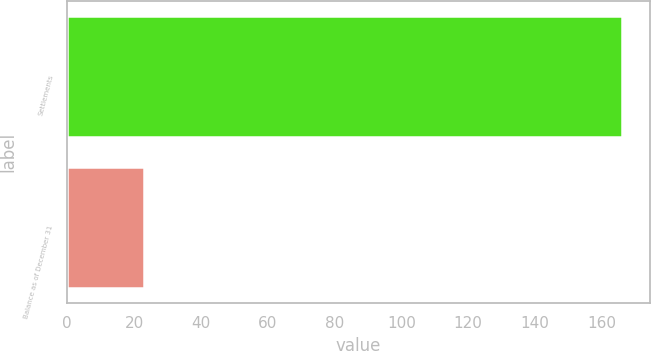Convert chart to OTSL. <chart><loc_0><loc_0><loc_500><loc_500><bar_chart><fcel>Settlements<fcel>Balance as of December 31<nl><fcel>166<fcel>23<nl></chart> 